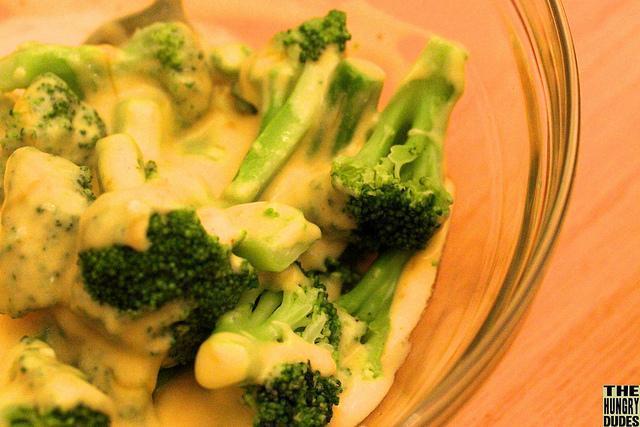How many broccolis can you see?
Give a very brief answer. 7. How many mice are on the desk?
Give a very brief answer. 0. 